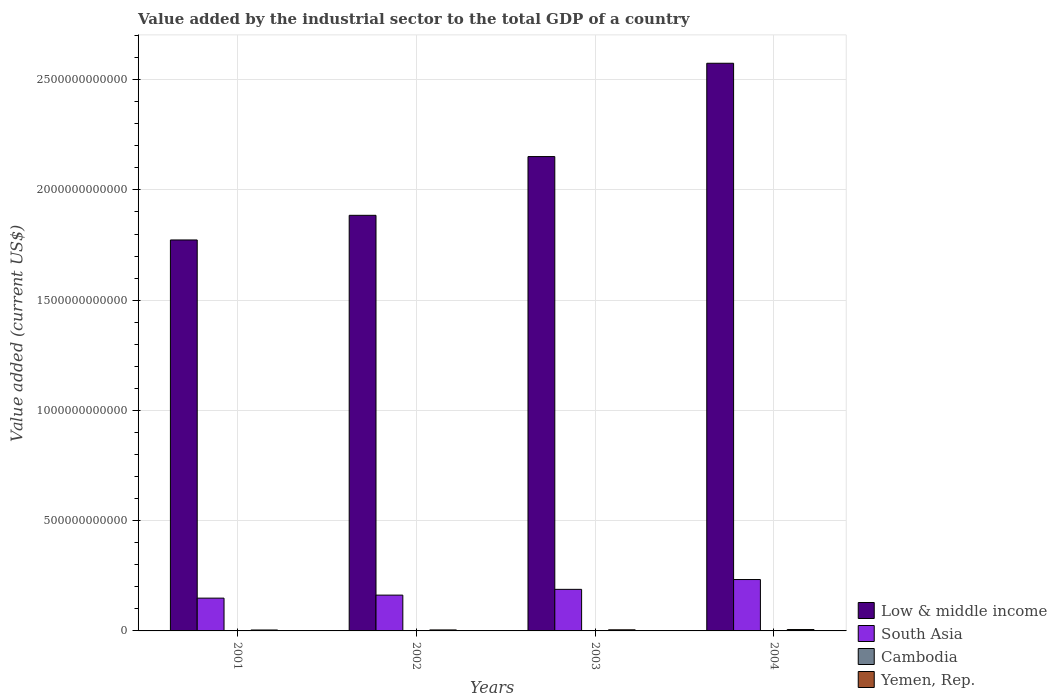How many groups of bars are there?
Ensure brevity in your answer.  4. Are the number of bars on each tick of the X-axis equal?
Offer a terse response. Yes. How many bars are there on the 3rd tick from the right?
Offer a very short reply. 4. What is the value added by the industrial sector to the total GDP in Yemen, Rep. in 2003?
Provide a succinct answer. 5.07e+09. Across all years, what is the maximum value added by the industrial sector to the total GDP in Low & middle income?
Offer a terse response. 2.57e+12. Across all years, what is the minimum value added by the industrial sector to the total GDP in South Asia?
Your response must be concise. 1.49e+11. In which year was the value added by the industrial sector to the total GDP in Cambodia minimum?
Your answer should be very brief. 2001. What is the total value added by the industrial sector to the total GDP in South Asia in the graph?
Make the answer very short. 7.33e+11. What is the difference between the value added by the industrial sector to the total GDP in Low & middle income in 2001 and that in 2002?
Provide a succinct answer. -1.12e+11. What is the difference between the value added by the industrial sector to the total GDP in Low & middle income in 2001 and the value added by the industrial sector to the total GDP in Yemen, Rep. in 2002?
Ensure brevity in your answer.  1.77e+12. What is the average value added by the industrial sector to the total GDP in South Asia per year?
Provide a short and direct response. 1.83e+11. In the year 2002, what is the difference between the value added by the industrial sector to the total GDP in Cambodia and value added by the industrial sector to the total GDP in Yemen, Rep.?
Offer a very short reply. -3.46e+09. What is the ratio of the value added by the industrial sector to the total GDP in Cambodia in 2002 to that in 2003?
Your answer should be compact. 0.89. Is the value added by the industrial sector to the total GDP in Low & middle income in 2001 less than that in 2004?
Offer a terse response. Yes. Is the difference between the value added by the industrial sector to the total GDP in Cambodia in 2001 and 2004 greater than the difference between the value added by the industrial sector to the total GDP in Yemen, Rep. in 2001 and 2004?
Offer a terse response. Yes. What is the difference between the highest and the second highest value added by the industrial sector to the total GDP in Low & middle income?
Give a very brief answer. 4.23e+11. What is the difference between the highest and the lowest value added by the industrial sector to the total GDP in South Asia?
Your answer should be compact. 8.43e+1. In how many years, is the value added by the industrial sector to the total GDP in Cambodia greater than the average value added by the industrial sector to the total GDP in Cambodia taken over all years?
Your answer should be compact. 2. Is the sum of the value added by the industrial sector to the total GDP in South Asia in 2002 and 2003 greater than the maximum value added by the industrial sector to the total GDP in Cambodia across all years?
Offer a very short reply. Yes. What does the 3rd bar from the left in 2002 represents?
Ensure brevity in your answer.  Cambodia. What does the 2nd bar from the right in 2004 represents?
Provide a succinct answer. Cambodia. Is it the case that in every year, the sum of the value added by the industrial sector to the total GDP in Yemen, Rep. and value added by the industrial sector to the total GDP in South Asia is greater than the value added by the industrial sector to the total GDP in Low & middle income?
Provide a succinct answer. No. What is the difference between two consecutive major ticks on the Y-axis?
Provide a succinct answer. 5.00e+11. Does the graph contain any zero values?
Offer a terse response. No. Where does the legend appear in the graph?
Provide a short and direct response. Bottom right. What is the title of the graph?
Make the answer very short. Value added by the industrial sector to the total GDP of a country. Does "Bangladesh" appear as one of the legend labels in the graph?
Your response must be concise. No. What is the label or title of the X-axis?
Offer a very short reply. Years. What is the label or title of the Y-axis?
Offer a terse response. Value added (current US$). What is the Value added (current US$) in Low & middle income in 2001?
Offer a terse response. 1.77e+12. What is the Value added (current US$) of South Asia in 2001?
Your response must be concise. 1.49e+11. What is the Value added (current US$) of Cambodia in 2001?
Your answer should be compact. 8.88e+08. What is the Value added (current US$) in Yemen, Rep. in 2001?
Your response must be concise. 4.18e+09. What is the Value added (current US$) of Low & middle income in 2002?
Offer a very short reply. 1.88e+12. What is the Value added (current US$) of South Asia in 2002?
Offer a terse response. 1.62e+11. What is the Value added (current US$) of Cambodia in 2002?
Your answer should be very brief. 1.04e+09. What is the Value added (current US$) in Yemen, Rep. in 2002?
Offer a terse response. 4.50e+09. What is the Value added (current US$) in Low & middle income in 2003?
Ensure brevity in your answer.  2.15e+12. What is the Value added (current US$) in South Asia in 2003?
Ensure brevity in your answer.  1.88e+11. What is the Value added (current US$) in Cambodia in 2003?
Offer a very short reply. 1.16e+09. What is the Value added (current US$) of Yemen, Rep. in 2003?
Offer a very short reply. 5.07e+09. What is the Value added (current US$) in Low & middle income in 2004?
Offer a terse response. 2.57e+12. What is the Value added (current US$) of South Asia in 2004?
Offer a terse response. 2.33e+11. What is the Value added (current US$) of Cambodia in 2004?
Keep it short and to the point. 1.37e+09. What is the Value added (current US$) in Yemen, Rep. in 2004?
Give a very brief answer. 6.27e+09. Across all years, what is the maximum Value added (current US$) of Low & middle income?
Your answer should be very brief. 2.57e+12. Across all years, what is the maximum Value added (current US$) in South Asia?
Provide a short and direct response. 2.33e+11. Across all years, what is the maximum Value added (current US$) of Cambodia?
Your response must be concise. 1.37e+09. Across all years, what is the maximum Value added (current US$) in Yemen, Rep.?
Your answer should be compact. 6.27e+09. Across all years, what is the minimum Value added (current US$) of Low & middle income?
Provide a short and direct response. 1.77e+12. Across all years, what is the minimum Value added (current US$) of South Asia?
Your answer should be very brief. 1.49e+11. Across all years, what is the minimum Value added (current US$) of Cambodia?
Offer a very short reply. 8.88e+08. Across all years, what is the minimum Value added (current US$) in Yemen, Rep.?
Make the answer very short. 4.18e+09. What is the total Value added (current US$) in Low & middle income in the graph?
Provide a short and direct response. 8.38e+12. What is the total Value added (current US$) of South Asia in the graph?
Make the answer very short. 7.33e+11. What is the total Value added (current US$) in Cambodia in the graph?
Ensure brevity in your answer.  4.46e+09. What is the total Value added (current US$) of Yemen, Rep. in the graph?
Ensure brevity in your answer.  2.00e+1. What is the difference between the Value added (current US$) in Low & middle income in 2001 and that in 2002?
Your answer should be compact. -1.12e+11. What is the difference between the Value added (current US$) in South Asia in 2001 and that in 2002?
Offer a terse response. -1.37e+1. What is the difference between the Value added (current US$) of Cambodia in 2001 and that in 2002?
Provide a short and direct response. -1.51e+08. What is the difference between the Value added (current US$) of Yemen, Rep. in 2001 and that in 2002?
Keep it short and to the point. -3.19e+08. What is the difference between the Value added (current US$) of Low & middle income in 2001 and that in 2003?
Ensure brevity in your answer.  -3.78e+11. What is the difference between the Value added (current US$) of South Asia in 2001 and that in 2003?
Provide a short and direct response. -3.98e+1. What is the difference between the Value added (current US$) in Cambodia in 2001 and that in 2003?
Give a very brief answer. -2.76e+08. What is the difference between the Value added (current US$) of Yemen, Rep. in 2001 and that in 2003?
Offer a very short reply. -8.85e+08. What is the difference between the Value added (current US$) in Low & middle income in 2001 and that in 2004?
Ensure brevity in your answer.  -8.01e+11. What is the difference between the Value added (current US$) of South Asia in 2001 and that in 2004?
Make the answer very short. -8.43e+1. What is the difference between the Value added (current US$) in Cambodia in 2001 and that in 2004?
Give a very brief answer. -4.81e+08. What is the difference between the Value added (current US$) in Yemen, Rep. in 2001 and that in 2004?
Your answer should be very brief. -2.08e+09. What is the difference between the Value added (current US$) of Low & middle income in 2002 and that in 2003?
Provide a short and direct response. -2.66e+11. What is the difference between the Value added (current US$) of South Asia in 2002 and that in 2003?
Provide a succinct answer. -2.61e+1. What is the difference between the Value added (current US$) in Cambodia in 2002 and that in 2003?
Give a very brief answer. -1.25e+08. What is the difference between the Value added (current US$) of Yemen, Rep. in 2002 and that in 2003?
Keep it short and to the point. -5.66e+08. What is the difference between the Value added (current US$) in Low & middle income in 2002 and that in 2004?
Offer a terse response. -6.90e+11. What is the difference between the Value added (current US$) in South Asia in 2002 and that in 2004?
Your answer should be very brief. -7.06e+1. What is the difference between the Value added (current US$) in Cambodia in 2002 and that in 2004?
Give a very brief answer. -3.30e+08. What is the difference between the Value added (current US$) in Yemen, Rep. in 2002 and that in 2004?
Provide a short and direct response. -1.77e+09. What is the difference between the Value added (current US$) in Low & middle income in 2003 and that in 2004?
Make the answer very short. -4.23e+11. What is the difference between the Value added (current US$) of South Asia in 2003 and that in 2004?
Offer a terse response. -4.45e+1. What is the difference between the Value added (current US$) in Cambodia in 2003 and that in 2004?
Make the answer very short. -2.05e+08. What is the difference between the Value added (current US$) of Yemen, Rep. in 2003 and that in 2004?
Give a very brief answer. -1.20e+09. What is the difference between the Value added (current US$) in Low & middle income in 2001 and the Value added (current US$) in South Asia in 2002?
Offer a very short reply. 1.61e+12. What is the difference between the Value added (current US$) in Low & middle income in 2001 and the Value added (current US$) in Cambodia in 2002?
Give a very brief answer. 1.77e+12. What is the difference between the Value added (current US$) in Low & middle income in 2001 and the Value added (current US$) in Yemen, Rep. in 2002?
Your answer should be compact. 1.77e+12. What is the difference between the Value added (current US$) of South Asia in 2001 and the Value added (current US$) of Cambodia in 2002?
Offer a terse response. 1.48e+11. What is the difference between the Value added (current US$) in South Asia in 2001 and the Value added (current US$) in Yemen, Rep. in 2002?
Provide a succinct answer. 1.44e+11. What is the difference between the Value added (current US$) in Cambodia in 2001 and the Value added (current US$) in Yemen, Rep. in 2002?
Offer a very short reply. -3.61e+09. What is the difference between the Value added (current US$) in Low & middle income in 2001 and the Value added (current US$) in South Asia in 2003?
Provide a short and direct response. 1.58e+12. What is the difference between the Value added (current US$) of Low & middle income in 2001 and the Value added (current US$) of Cambodia in 2003?
Keep it short and to the point. 1.77e+12. What is the difference between the Value added (current US$) in Low & middle income in 2001 and the Value added (current US$) in Yemen, Rep. in 2003?
Offer a very short reply. 1.77e+12. What is the difference between the Value added (current US$) of South Asia in 2001 and the Value added (current US$) of Cambodia in 2003?
Your response must be concise. 1.48e+11. What is the difference between the Value added (current US$) of South Asia in 2001 and the Value added (current US$) of Yemen, Rep. in 2003?
Keep it short and to the point. 1.44e+11. What is the difference between the Value added (current US$) of Cambodia in 2001 and the Value added (current US$) of Yemen, Rep. in 2003?
Offer a terse response. -4.18e+09. What is the difference between the Value added (current US$) in Low & middle income in 2001 and the Value added (current US$) in South Asia in 2004?
Make the answer very short. 1.54e+12. What is the difference between the Value added (current US$) of Low & middle income in 2001 and the Value added (current US$) of Cambodia in 2004?
Your answer should be compact. 1.77e+12. What is the difference between the Value added (current US$) in Low & middle income in 2001 and the Value added (current US$) in Yemen, Rep. in 2004?
Keep it short and to the point. 1.77e+12. What is the difference between the Value added (current US$) of South Asia in 2001 and the Value added (current US$) of Cambodia in 2004?
Give a very brief answer. 1.47e+11. What is the difference between the Value added (current US$) in South Asia in 2001 and the Value added (current US$) in Yemen, Rep. in 2004?
Your answer should be very brief. 1.42e+11. What is the difference between the Value added (current US$) in Cambodia in 2001 and the Value added (current US$) in Yemen, Rep. in 2004?
Your answer should be compact. -5.38e+09. What is the difference between the Value added (current US$) in Low & middle income in 2002 and the Value added (current US$) in South Asia in 2003?
Provide a short and direct response. 1.70e+12. What is the difference between the Value added (current US$) in Low & middle income in 2002 and the Value added (current US$) in Cambodia in 2003?
Offer a very short reply. 1.88e+12. What is the difference between the Value added (current US$) in Low & middle income in 2002 and the Value added (current US$) in Yemen, Rep. in 2003?
Your answer should be very brief. 1.88e+12. What is the difference between the Value added (current US$) in South Asia in 2002 and the Value added (current US$) in Cambodia in 2003?
Your response must be concise. 1.61e+11. What is the difference between the Value added (current US$) of South Asia in 2002 and the Value added (current US$) of Yemen, Rep. in 2003?
Make the answer very short. 1.57e+11. What is the difference between the Value added (current US$) in Cambodia in 2002 and the Value added (current US$) in Yemen, Rep. in 2003?
Your answer should be very brief. -4.03e+09. What is the difference between the Value added (current US$) in Low & middle income in 2002 and the Value added (current US$) in South Asia in 2004?
Offer a very short reply. 1.65e+12. What is the difference between the Value added (current US$) of Low & middle income in 2002 and the Value added (current US$) of Cambodia in 2004?
Offer a very short reply. 1.88e+12. What is the difference between the Value added (current US$) of Low & middle income in 2002 and the Value added (current US$) of Yemen, Rep. in 2004?
Keep it short and to the point. 1.88e+12. What is the difference between the Value added (current US$) in South Asia in 2002 and the Value added (current US$) in Cambodia in 2004?
Your response must be concise. 1.61e+11. What is the difference between the Value added (current US$) in South Asia in 2002 and the Value added (current US$) in Yemen, Rep. in 2004?
Your response must be concise. 1.56e+11. What is the difference between the Value added (current US$) in Cambodia in 2002 and the Value added (current US$) in Yemen, Rep. in 2004?
Make the answer very short. -5.23e+09. What is the difference between the Value added (current US$) in Low & middle income in 2003 and the Value added (current US$) in South Asia in 2004?
Offer a very short reply. 1.92e+12. What is the difference between the Value added (current US$) in Low & middle income in 2003 and the Value added (current US$) in Cambodia in 2004?
Ensure brevity in your answer.  2.15e+12. What is the difference between the Value added (current US$) of Low & middle income in 2003 and the Value added (current US$) of Yemen, Rep. in 2004?
Your response must be concise. 2.14e+12. What is the difference between the Value added (current US$) in South Asia in 2003 and the Value added (current US$) in Cambodia in 2004?
Make the answer very short. 1.87e+11. What is the difference between the Value added (current US$) of South Asia in 2003 and the Value added (current US$) of Yemen, Rep. in 2004?
Make the answer very short. 1.82e+11. What is the difference between the Value added (current US$) of Cambodia in 2003 and the Value added (current US$) of Yemen, Rep. in 2004?
Offer a very short reply. -5.10e+09. What is the average Value added (current US$) of Low & middle income per year?
Ensure brevity in your answer.  2.10e+12. What is the average Value added (current US$) of South Asia per year?
Provide a succinct answer. 1.83e+11. What is the average Value added (current US$) of Cambodia per year?
Offer a terse response. 1.11e+09. What is the average Value added (current US$) in Yemen, Rep. per year?
Make the answer very short. 5.00e+09. In the year 2001, what is the difference between the Value added (current US$) in Low & middle income and Value added (current US$) in South Asia?
Offer a very short reply. 1.62e+12. In the year 2001, what is the difference between the Value added (current US$) of Low & middle income and Value added (current US$) of Cambodia?
Your response must be concise. 1.77e+12. In the year 2001, what is the difference between the Value added (current US$) of Low & middle income and Value added (current US$) of Yemen, Rep.?
Your answer should be very brief. 1.77e+12. In the year 2001, what is the difference between the Value added (current US$) of South Asia and Value added (current US$) of Cambodia?
Offer a very short reply. 1.48e+11. In the year 2001, what is the difference between the Value added (current US$) in South Asia and Value added (current US$) in Yemen, Rep.?
Provide a succinct answer. 1.45e+11. In the year 2001, what is the difference between the Value added (current US$) of Cambodia and Value added (current US$) of Yemen, Rep.?
Give a very brief answer. -3.29e+09. In the year 2002, what is the difference between the Value added (current US$) in Low & middle income and Value added (current US$) in South Asia?
Your answer should be very brief. 1.72e+12. In the year 2002, what is the difference between the Value added (current US$) of Low & middle income and Value added (current US$) of Cambodia?
Your response must be concise. 1.88e+12. In the year 2002, what is the difference between the Value added (current US$) of Low & middle income and Value added (current US$) of Yemen, Rep.?
Provide a succinct answer. 1.88e+12. In the year 2002, what is the difference between the Value added (current US$) of South Asia and Value added (current US$) of Cambodia?
Make the answer very short. 1.61e+11. In the year 2002, what is the difference between the Value added (current US$) in South Asia and Value added (current US$) in Yemen, Rep.?
Ensure brevity in your answer.  1.58e+11. In the year 2002, what is the difference between the Value added (current US$) in Cambodia and Value added (current US$) in Yemen, Rep.?
Ensure brevity in your answer.  -3.46e+09. In the year 2003, what is the difference between the Value added (current US$) of Low & middle income and Value added (current US$) of South Asia?
Keep it short and to the point. 1.96e+12. In the year 2003, what is the difference between the Value added (current US$) of Low & middle income and Value added (current US$) of Cambodia?
Give a very brief answer. 2.15e+12. In the year 2003, what is the difference between the Value added (current US$) in Low & middle income and Value added (current US$) in Yemen, Rep.?
Make the answer very short. 2.15e+12. In the year 2003, what is the difference between the Value added (current US$) in South Asia and Value added (current US$) in Cambodia?
Provide a short and direct response. 1.87e+11. In the year 2003, what is the difference between the Value added (current US$) of South Asia and Value added (current US$) of Yemen, Rep.?
Give a very brief answer. 1.83e+11. In the year 2003, what is the difference between the Value added (current US$) of Cambodia and Value added (current US$) of Yemen, Rep.?
Make the answer very short. -3.90e+09. In the year 2004, what is the difference between the Value added (current US$) in Low & middle income and Value added (current US$) in South Asia?
Provide a short and direct response. 2.34e+12. In the year 2004, what is the difference between the Value added (current US$) in Low & middle income and Value added (current US$) in Cambodia?
Provide a short and direct response. 2.57e+12. In the year 2004, what is the difference between the Value added (current US$) in Low & middle income and Value added (current US$) in Yemen, Rep.?
Keep it short and to the point. 2.57e+12. In the year 2004, what is the difference between the Value added (current US$) of South Asia and Value added (current US$) of Cambodia?
Give a very brief answer. 2.32e+11. In the year 2004, what is the difference between the Value added (current US$) in South Asia and Value added (current US$) in Yemen, Rep.?
Give a very brief answer. 2.27e+11. In the year 2004, what is the difference between the Value added (current US$) of Cambodia and Value added (current US$) of Yemen, Rep.?
Provide a short and direct response. -4.90e+09. What is the ratio of the Value added (current US$) in Low & middle income in 2001 to that in 2002?
Your response must be concise. 0.94. What is the ratio of the Value added (current US$) in South Asia in 2001 to that in 2002?
Ensure brevity in your answer.  0.92. What is the ratio of the Value added (current US$) in Cambodia in 2001 to that in 2002?
Give a very brief answer. 0.85. What is the ratio of the Value added (current US$) in Yemen, Rep. in 2001 to that in 2002?
Your response must be concise. 0.93. What is the ratio of the Value added (current US$) of Low & middle income in 2001 to that in 2003?
Offer a terse response. 0.82. What is the ratio of the Value added (current US$) in South Asia in 2001 to that in 2003?
Give a very brief answer. 0.79. What is the ratio of the Value added (current US$) of Cambodia in 2001 to that in 2003?
Your response must be concise. 0.76. What is the ratio of the Value added (current US$) of Yemen, Rep. in 2001 to that in 2003?
Make the answer very short. 0.83. What is the ratio of the Value added (current US$) of Low & middle income in 2001 to that in 2004?
Your response must be concise. 0.69. What is the ratio of the Value added (current US$) in South Asia in 2001 to that in 2004?
Offer a very short reply. 0.64. What is the ratio of the Value added (current US$) of Cambodia in 2001 to that in 2004?
Provide a succinct answer. 0.65. What is the ratio of the Value added (current US$) in Yemen, Rep. in 2001 to that in 2004?
Offer a very short reply. 0.67. What is the ratio of the Value added (current US$) in Low & middle income in 2002 to that in 2003?
Keep it short and to the point. 0.88. What is the ratio of the Value added (current US$) of South Asia in 2002 to that in 2003?
Keep it short and to the point. 0.86. What is the ratio of the Value added (current US$) of Cambodia in 2002 to that in 2003?
Your answer should be compact. 0.89. What is the ratio of the Value added (current US$) in Yemen, Rep. in 2002 to that in 2003?
Provide a short and direct response. 0.89. What is the ratio of the Value added (current US$) of Low & middle income in 2002 to that in 2004?
Offer a very short reply. 0.73. What is the ratio of the Value added (current US$) in South Asia in 2002 to that in 2004?
Offer a very short reply. 0.7. What is the ratio of the Value added (current US$) in Cambodia in 2002 to that in 2004?
Ensure brevity in your answer.  0.76. What is the ratio of the Value added (current US$) in Yemen, Rep. in 2002 to that in 2004?
Make the answer very short. 0.72. What is the ratio of the Value added (current US$) of Low & middle income in 2003 to that in 2004?
Provide a succinct answer. 0.84. What is the ratio of the Value added (current US$) of South Asia in 2003 to that in 2004?
Make the answer very short. 0.81. What is the ratio of the Value added (current US$) of Cambodia in 2003 to that in 2004?
Offer a terse response. 0.85. What is the ratio of the Value added (current US$) in Yemen, Rep. in 2003 to that in 2004?
Make the answer very short. 0.81. What is the difference between the highest and the second highest Value added (current US$) in Low & middle income?
Your answer should be very brief. 4.23e+11. What is the difference between the highest and the second highest Value added (current US$) in South Asia?
Ensure brevity in your answer.  4.45e+1. What is the difference between the highest and the second highest Value added (current US$) of Cambodia?
Your answer should be compact. 2.05e+08. What is the difference between the highest and the second highest Value added (current US$) in Yemen, Rep.?
Keep it short and to the point. 1.20e+09. What is the difference between the highest and the lowest Value added (current US$) of Low & middle income?
Provide a succinct answer. 8.01e+11. What is the difference between the highest and the lowest Value added (current US$) of South Asia?
Offer a terse response. 8.43e+1. What is the difference between the highest and the lowest Value added (current US$) in Cambodia?
Make the answer very short. 4.81e+08. What is the difference between the highest and the lowest Value added (current US$) in Yemen, Rep.?
Give a very brief answer. 2.08e+09. 